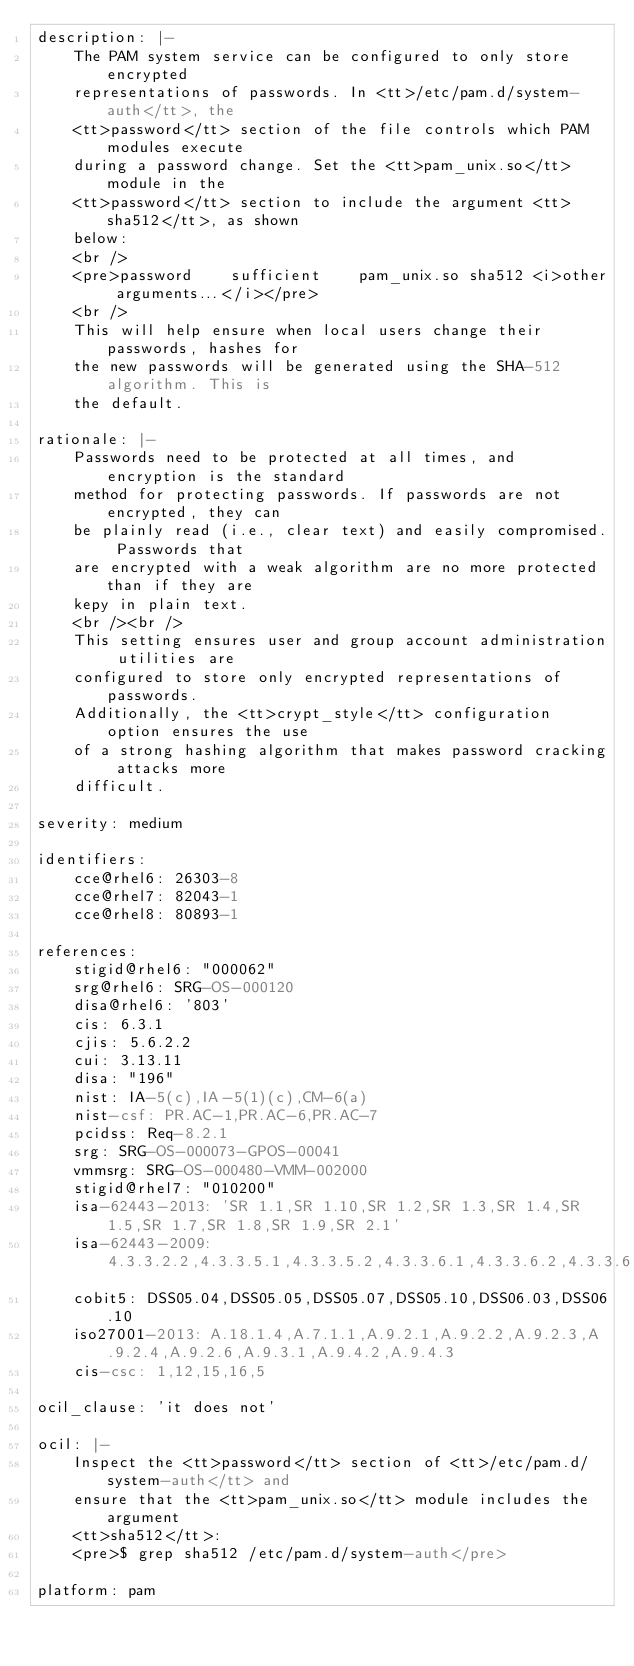Convert code to text. <code><loc_0><loc_0><loc_500><loc_500><_YAML_>description: |-
    The PAM system service can be configured to only store encrypted
    representations of passwords. In <tt>/etc/pam.d/system-auth</tt>, the
    <tt>password</tt> section of the file controls which PAM modules execute
    during a password change. Set the <tt>pam_unix.so</tt> module in the
    <tt>password</tt> section to include the argument <tt>sha512</tt>, as shown
    below:
    <br />
    <pre>password    sufficient    pam_unix.so sha512 <i>other arguments...</i></pre>
    <br />
    This will help ensure when local users change their passwords, hashes for
    the new passwords will be generated using the SHA-512 algorithm. This is
    the default.

rationale: |-
    Passwords need to be protected at all times, and encryption is the standard
    method for protecting passwords. If passwords are not encrypted, they can
    be plainly read (i.e., clear text) and easily compromised. Passwords that
    are encrypted with a weak algorithm are no more protected than if they are
    kepy in plain text.
    <br /><br />
    This setting ensures user and group account administration utilities are
    configured to store only encrypted representations of passwords.
    Additionally, the <tt>crypt_style</tt> configuration option ensures the use
    of a strong hashing algorithm that makes password cracking attacks more
    difficult.

severity: medium

identifiers:
    cce@rhel6: 26303-8
    cce@rhel7: 82043-1
    cce@rhel8: 80893-1

references:
    stigid@rhel6: "000062"
    srg@rhel6: SRG-OS-000120
    disa@rhel6: '803'
    cis: 6.3.1
    cjis: 5.6.2.2
    cui: 3.13.11
    disa: "196"
    nist: IA-5(c),IA-5(1)(c),CM-6(a)
    nist-csf: PR.AC-1,PR.AC-6,PR.AC-7
    pcidss: Req-8.2.1
    srg: SRG-OS-000073-GPOS-00041
    vmmsrg: SRG-OS-000480-VMM-002000
    stigid@rhel7: "010200"
    isa-62443-2013: 'SR 1.1,SR 1.10,SR 1.2,SR 1.3,SR 1.4,SR 1.5,SR 1.7,SR 1.8,SR 1.9,SR 2.1'
    isa-62443-2009: 4.3.3.2.2,4.3.3.5.1,4.3.3.5.2,4.3.3.6.1,4.3.3.6.2,4.3.3.6.3,4.3.3.6.4,4.3.3.6.5,4.3.3.6.6,4.3.3.6.7,4.3.3.6.8,4.3.3.6.9,4.3.3.7.2,4.3.3.7.4
    cobit5: DSS05.04,DSS05.05,DSS05.07,DSS05.10,DSS06.03,DSS06.10
    iso27001-2013: A.18.1.4,A.7.1.1,A.9.2.1,A.9.2.2,A.9.2.3,A.9.2.4,A.9.2.6,A.9.3.1,A.9.4.2,A.9.4.3
    cis-csc: 1,12,15,16,5

ocil_clause: 'it does not'

ocil: |-
    Inspect the <tt>password</tt> section of <tt>/etc/pam.d/system-auth</tt> and
    ensure that the <tt>pam_unix.so</tt> module includes the argument
    <tt>sha512</tt>:
    <pre>$ grep sha512 /etc/pam.d/system-auth</pre>

platform: pam
</code> 